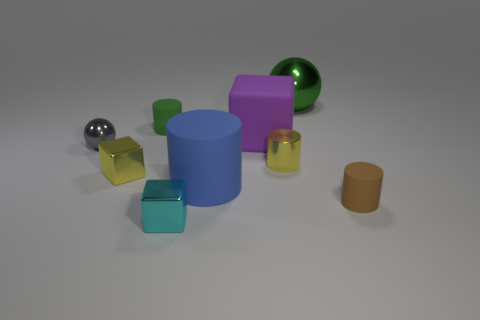Subtract all blue cylinders. How many cylinders are left? 3 Subtract all tiny cubes. How many cubes are left? 1 Subtract 1 cubes. How many cubes are left? 2 Add 1 matte cylinders. How many objects exist? 10 Subtract all purple cylinders. Subtract all red blocks. How many cylinders are left? 4 Subtract all spheres. How many objects are left? 7 Add 9 big blue things. How many big blue things exist? 10 Subtract 0 brown blocks. How many objects are left? 9 Subtract all small purple metallic blocks. Subtract all yellow shiny things. How many objects are left? 7 Add 6 large purple rubber objects. How many large purple rubber objects are left? 7 